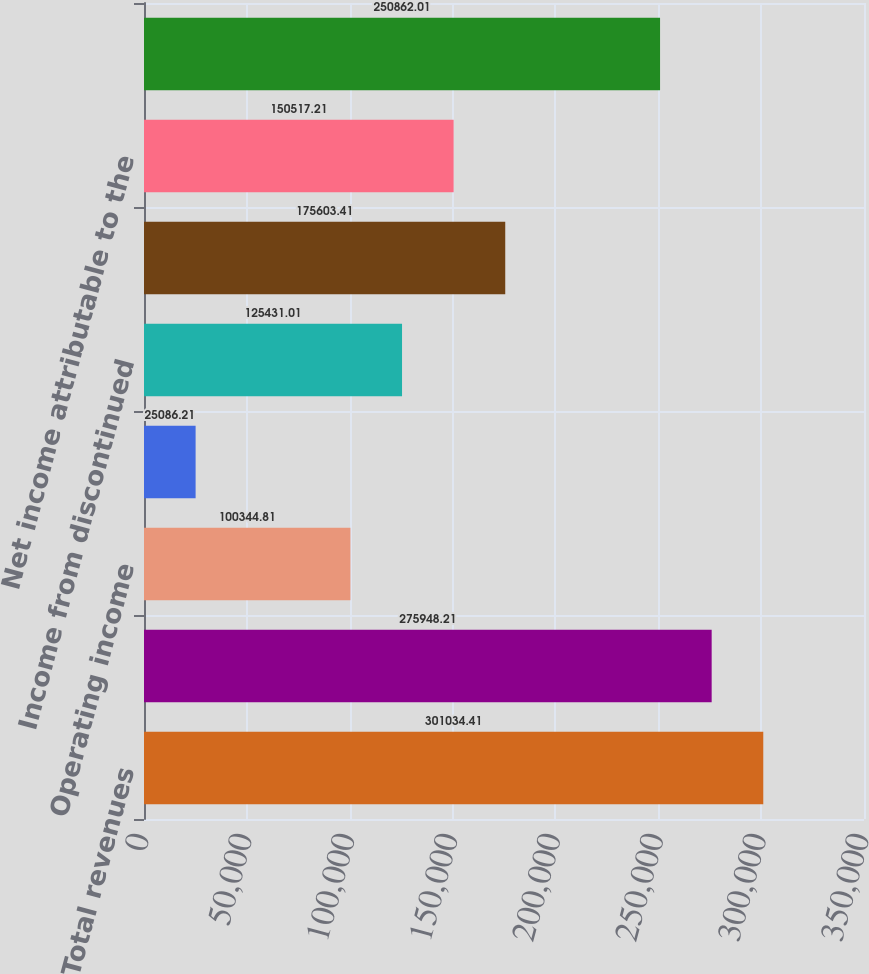<chart> <loc_0><loc_0><loc_500><loc_500><bar_chart><fcel>Total revenues<fcel>Total operating expenses<fcel>Operating income<fcel>(Loss) income from continuing<fcel>Income from discontinued<fcel>Net income<fcel>Net income attributable to the<fcel>Weighted average common units<nl><fcel>301034<fcel>275948<fcel>100345<fcel>25086.2<fcel>125431<fcel>175603<fcel>150517<fcel>250862<nl></chart> 